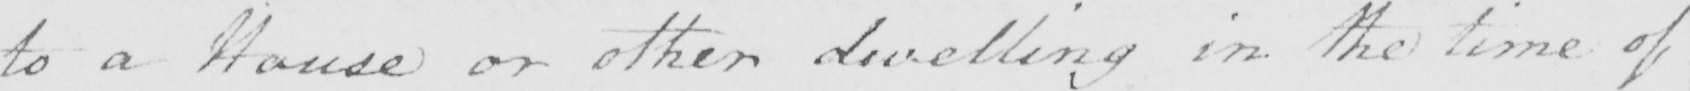Please transcribe the handwritten text in this image. to a House or other dwelling in the time of 